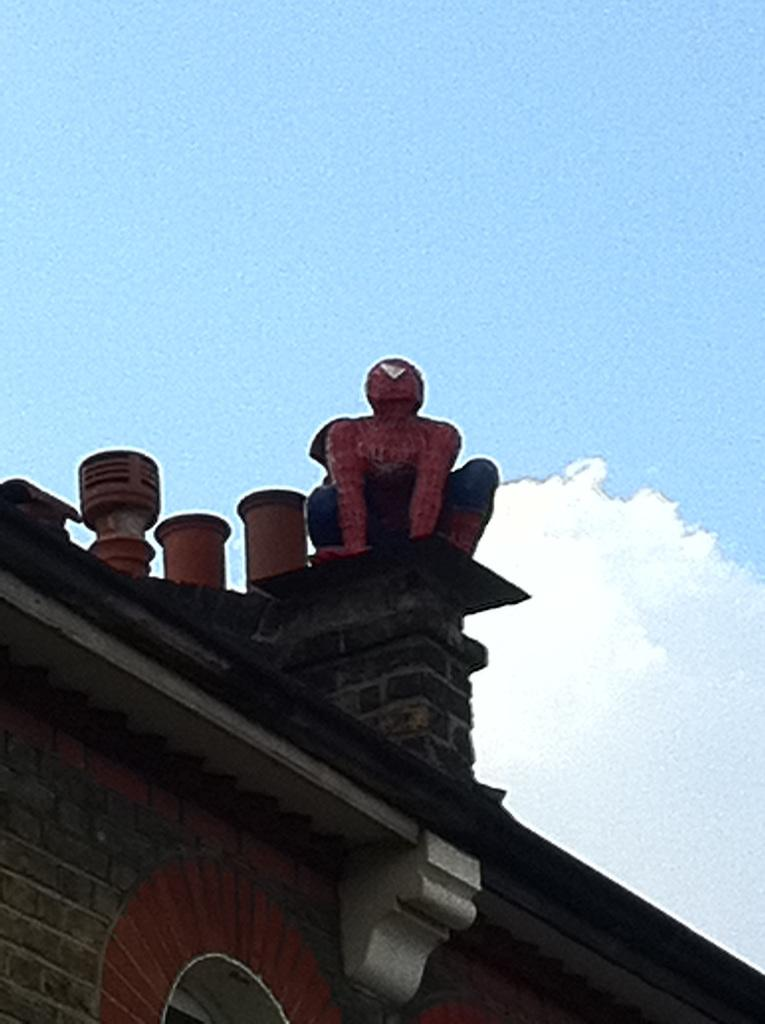What is on the wall of the building in the image? There is a spider's man statue on the wall of the building. What type of structure is the building in the image? The building has a roof and a brick wall. What can be seen in the background of the image? There are clouds in the blue sky in the background. How many nails can be seen holding the spider's man statue to the wall in the image? There is no mention of nails in the image, and the statue's attachment to the wall is not visible. What type of mark can be seen on the spider's man statue in the image? There is no mention of any marks on the spider's man statue in the image. 